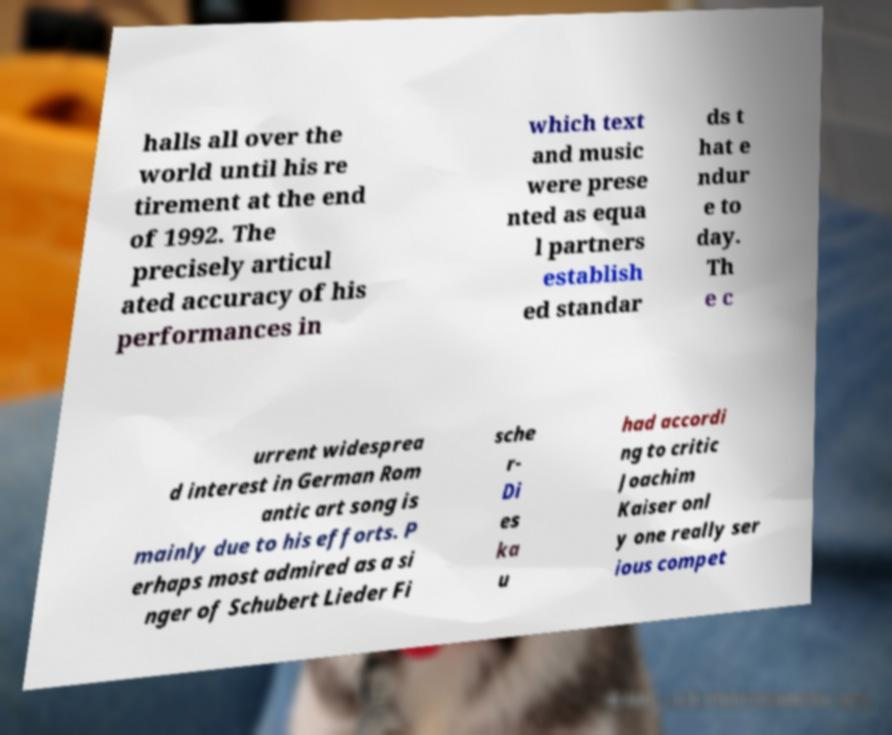Please read and relay the text visible in this image. What does it say? halls all over the world until his re tirement at the end of 1992. The precisely articul ated accuracy of his performances in which text and music were prese nted as equa l partners establish ed standar ds t hat e ndur e to day. Th e c urrent widesprea d interest in German Rom antic art song is mainly due to his efforts. P erhaps most admired as a si nger of Schubert Lieder Fi sche r- Di es ka u had accordi ng to critic Joachim Kaiser onl y one really ser ious compet 